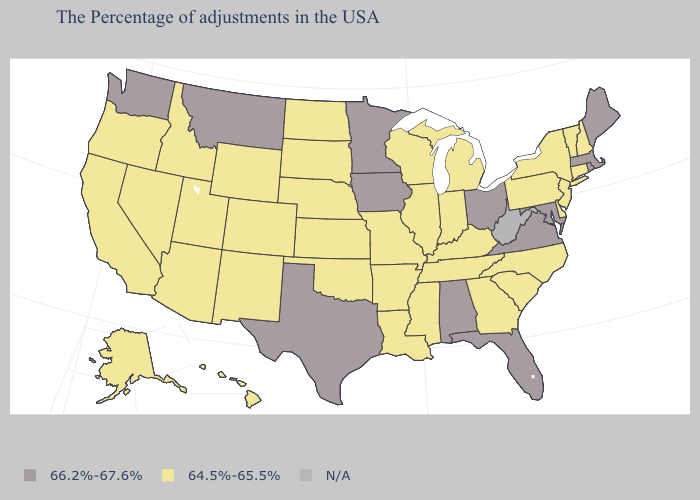What is the lowest value in the West?
Be succinct. 64.5%-65.5%. Name the states that have a value in the range 64.5%-65.5%?
Write a very short answer. New Hampshire, Vermont, Connecticut, New York, New Jersey, Delaware, Pennsylvania, North Carolina, South Carolina, Georgia, Michigan, Kentucky, Indiana, Tennessee, Wisconsin, Illinois, Mississippi, Louisiana, Missouri, Arkansas, Kansas, Nebraska, Oklahoma, South Dakota, North Dakota, Wyoming, Colorado, New Mexico, Utah, Arizona, Idaho, Nevada, California, Oregon, Alaska, Hawaii. Among the states that border Delaware , does New Jersey have the lowest value?
Concise answer only. Yes. What is the value of Maine?
Keep it brief. 66.2%-67.6%. What is the value of Maryland?
Concise answer only. 66.2%-67.6%. What is the value of Vermont?
Give a very brief answer. 64.5%-65.5%. What is the lowest value in the USA?
Keep it brief. 64.5%-65.5%. What is the value of Nebraska?
Write a very short answer. 64.5%-65.5%. What is the value of Wisconsin?
Keep it brief. 64.5%-65.5%. Among the states that border Mississippi , does Alabama have the lowest value?
Give a very brief answer. No. Name the states that have a value in the range 64.5%-65.5%?
Give a very brief answer. New Hampshire, Vermont, Connecticut, New York, New Jersey, Delaware, Pennsylvania, North Carolina, South Carolina, Georgia, Michigan, Kentucky, Indiana, Tennessee, Wisconsin, Illinois, Mississippi, Louisiana, Missouri, Arkansas, Kansas, Nebraska, Oklahoma, South Dakota, North Dakota, Wyoming, Colorado, New Mexico, Utah, Arizona, Idaho, Nevada, California, Oregon, Alaska, Hawaii. Does Maine have the highest value in the Northeast?
Concise answer only. Yes. Among the states that border Missouri , which have the lowest value?
Quick response, please. Kentucky, Tennessee, Illinois, Arkansas, Kansas, Nebraska, Oklahoma. What is the lowest value in states that border Alabama?
Be succinct. 64.5%-65.5%. 